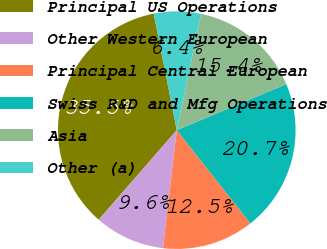Convert chart to OTSL. <chart><loc_0><loc_0><loc_500><loc_500><pie_chart><fcel>Principal US Operations<fcel>Other Western European<fcel>Principal Central European<fcel>Swiss R&D and Mfg Operations<fcel>Asia<fcel>Other (a)<nl><fcel>35.47%<fcel>9.57%<fcel>12.48%<fcel>20.69%<fcel>15.39%<fcel>6.38%<nl></chart> 